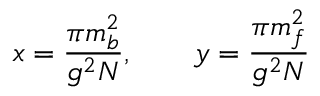Convert formula to latex. <formula><loc_0><loc_0><loc_500><loc_500>x = \frac { \pi m _ { b } ^ { 2 } } { g ^ { 2 } N } , \quad y = \frac { \pi m _ { f } ^ { 2 } } { g ^ { 2 } N }</formula> 